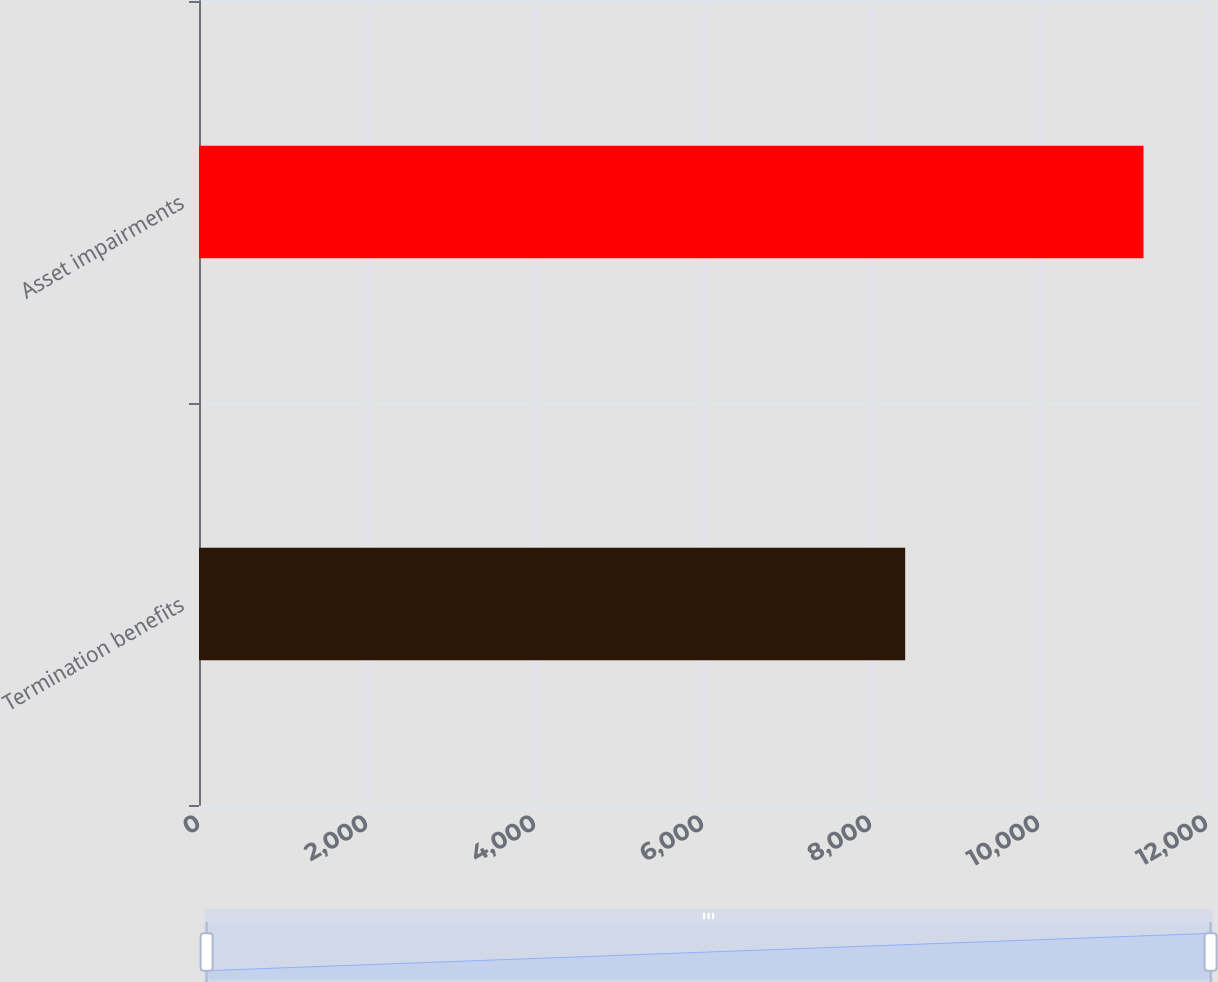<chart> <loc_0><loc_0><loc_500><loc_500><bar_chart><fcel>Termination benefits<fcel>Asset impairments<nl><fcel>8407<fcel>11244<nl></chart> 